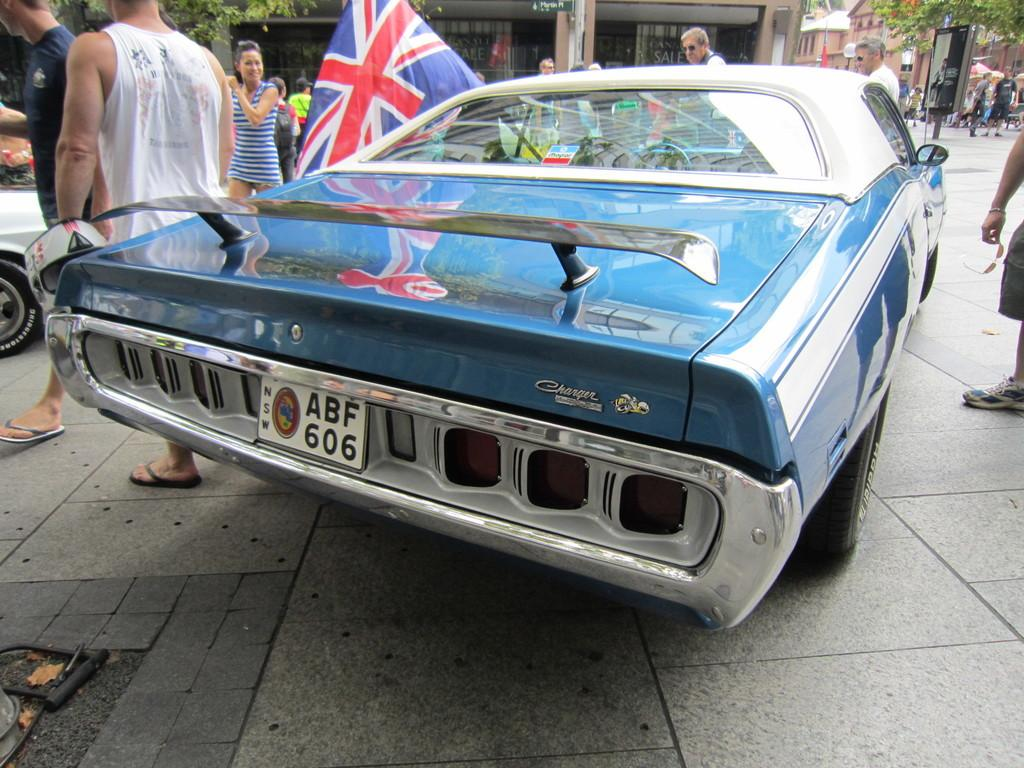<image>
Provide a brief description of the given image. The funky blue car has the registration ABF 606 